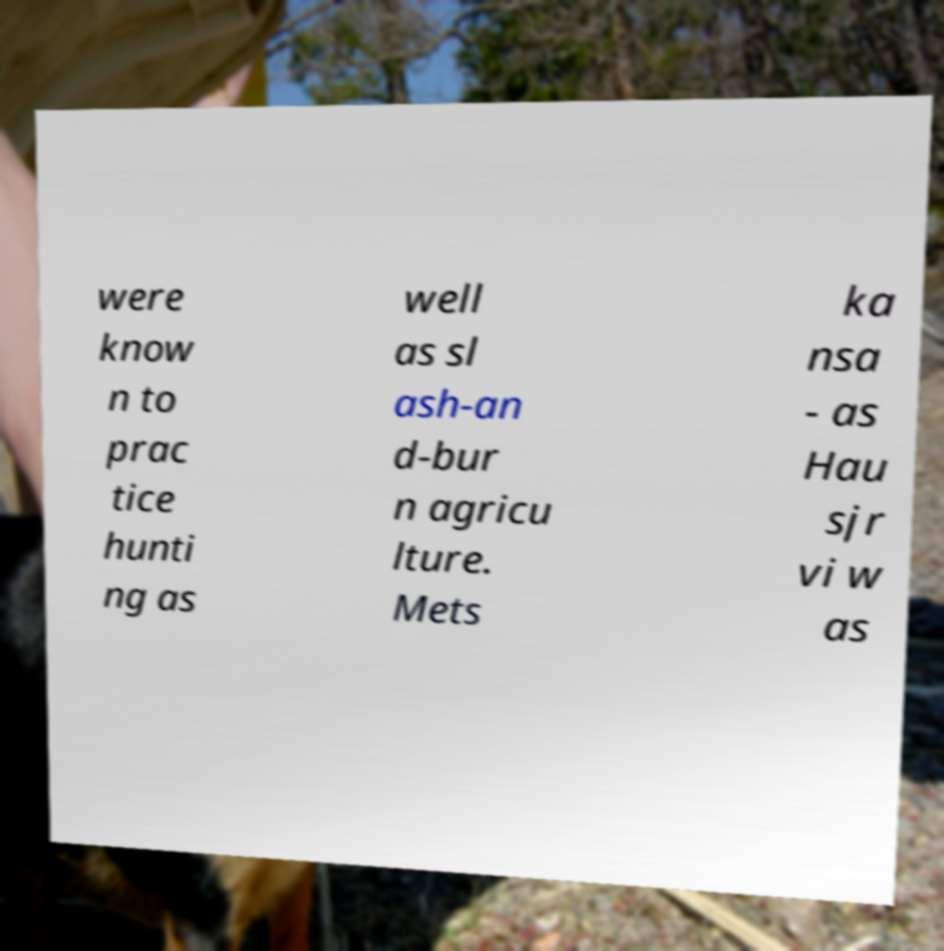Can you read and provide the text displayed in the image?This photo seems to have some interesting text. Can you extract and type it out for me? were know n to prac tice hunti ng as well as sl ash-an d-bur n agricu lture. Mets ka nsa - as Hau sjr vi w as 